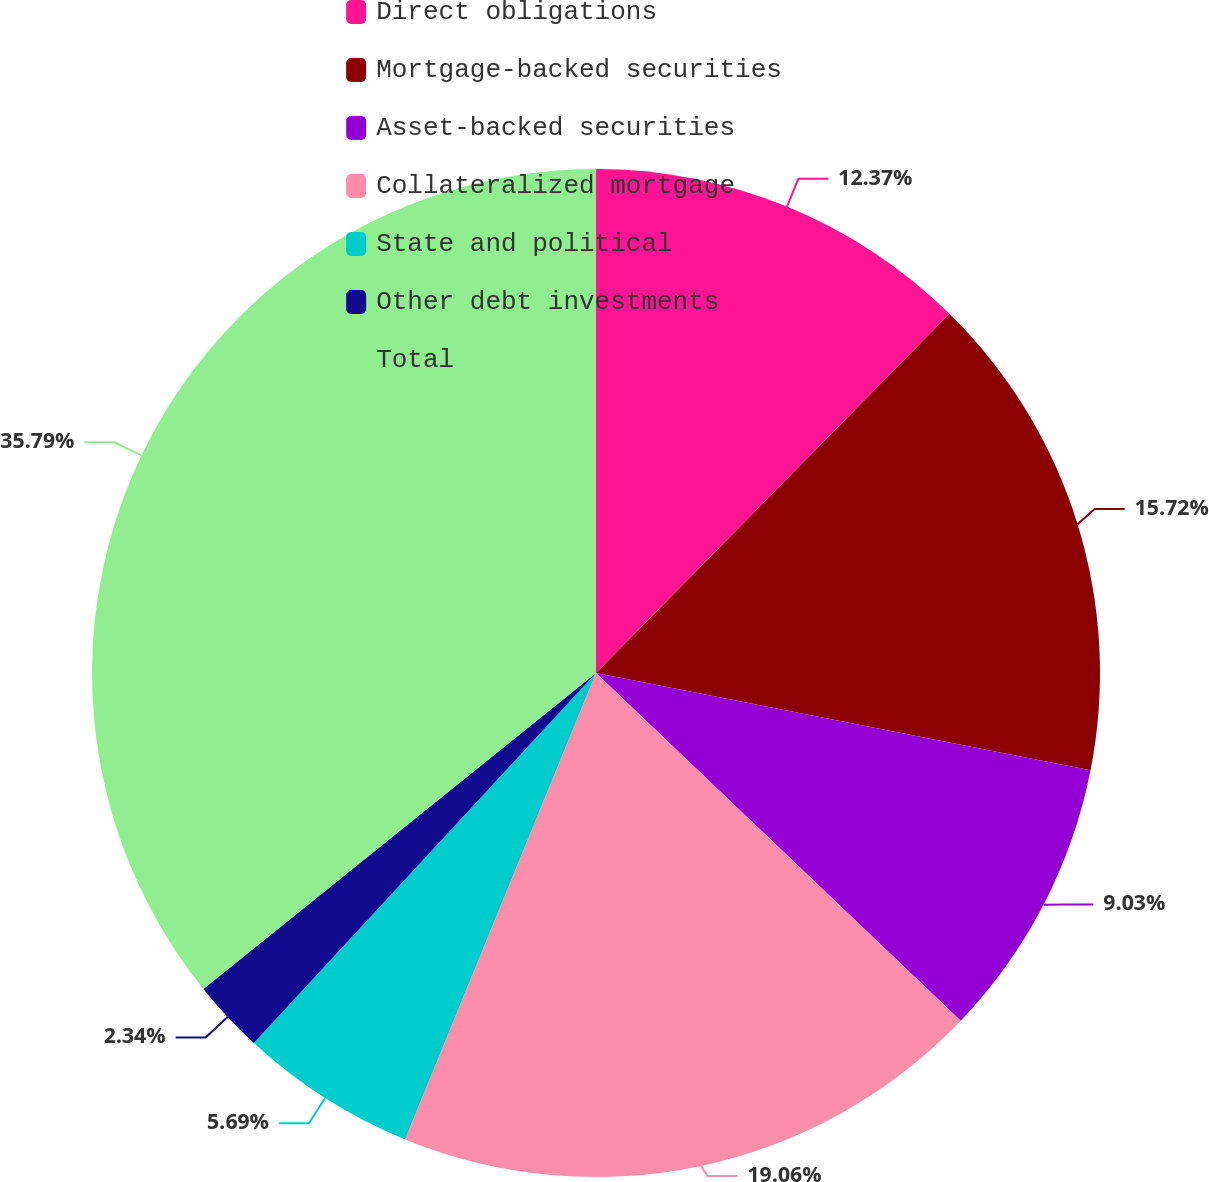Convert chart to OTSL. <chart><loc_0><loc_0><loc_500><loc_500><pie_chart><fcel>Direct obligations<fcel>Mortgage-backed securities<fcel>Asset-backed securities<fcel>Collateralized mortgage<fcel>State and political<fcel>Other debt investments<fcel>Total<nl><fcel>12.37%<fcel>15.72%<fcel>9.03%<fcel>19.06%<fcel>5.69%<fcel>2.34%<fcel>35.78%<nl></chart> 